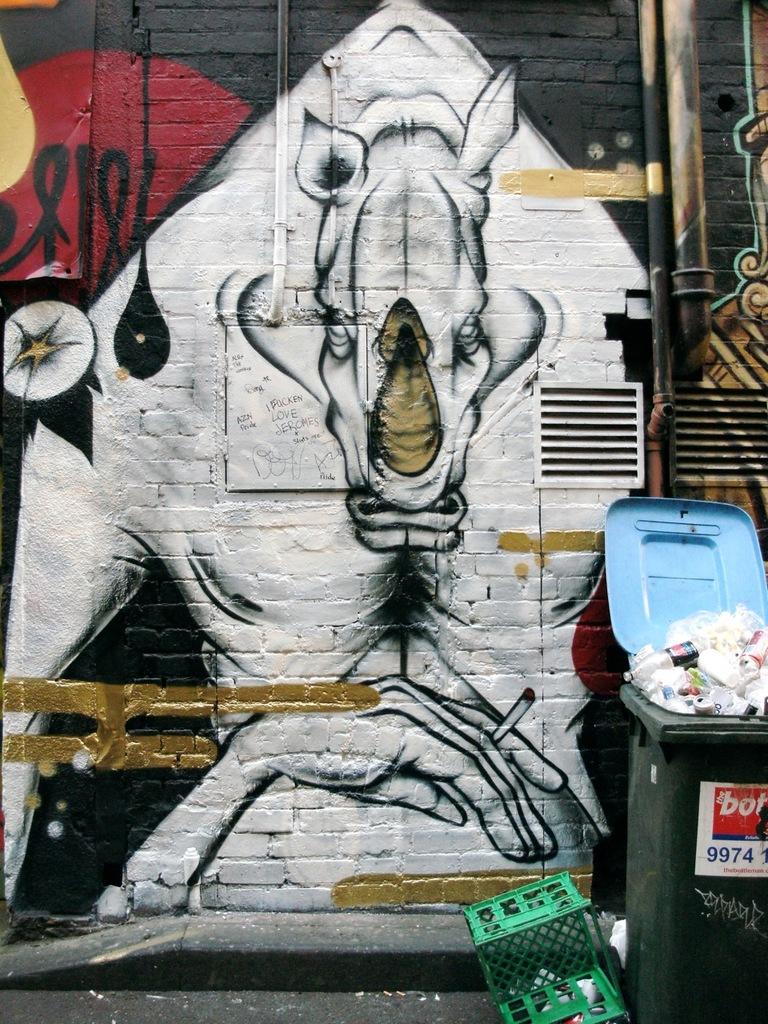What 4 digit number is written on the trash bin?
Provide a short and direct response. 9974. What animal is painted on the wall?
Your response must be concise. Answering does not require reading text in the image. 